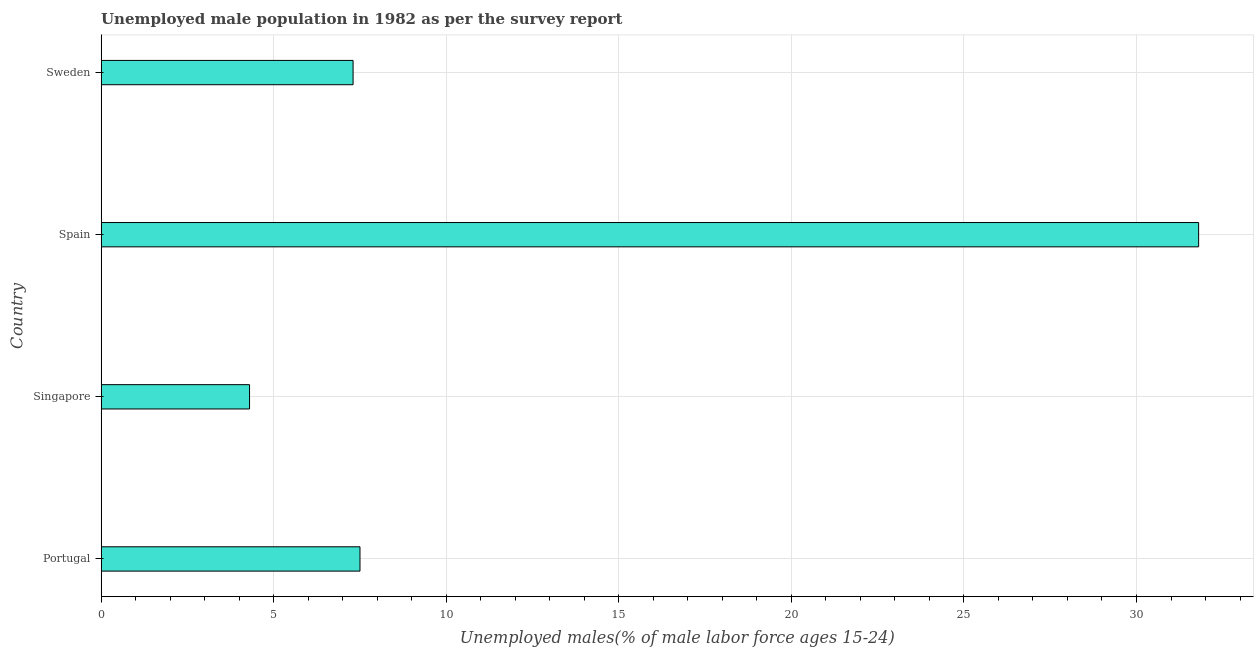Does the graph contain any zero values?
Your answer should be very brief. No. What is the title of the graph?
Provide a succinct answer. Unemployed male population in 1982 as per the survey report. What is the label or title of the X-axis?
Your answer should be very brief. Unemployed males(% of male labor force ages 15-24). What is the label or title of the Y-axis?
Your response must be concise. Country. What is the unemployed male youth in Spain?
Give a very brief answer. 31.8. Across all countries, what is the maximum unemployed male youth?
Ensure brevity in your answer.  31.8. Across all countries, what is the minimum unemployed male youth?
Give a very brief answer. 4.3. In which country was the unemployed male youth minimum?
Provide a short and direct response. Singapore. What is the sum of the unemployed male youth?
Ensure brevity in your answer.  50.9. What is the difference between the unemployed male youth in Portugal and Spain?
Make the answer very short. -24.3. What is the average unemployed male youth per country?
Ensure brevity in your answer.  12.72. What is the median unemployed male youth?
Your answer should be compact. 7.4. What is the ratio of the unemployed male youth in Portugal to that in Singapore?
Make the answer very short. 1.74. What is the difference between the highest and the second highest unemployed male youth?
Make the answer very short. 24.3. What is the difference between the highest and the lowest unemployed male youth?
Give a very brief answer. 27.5. Are all the bars in the graph horizontal?
Give a very brief answer. Yes. How many countries are there in the graph?
Your answer should be very brief. 4. What is the difference between two consecutive major ticks on the X-axis?
Offer a very short reply. 5. Are the values on the major ticks of X-axis written in scientific E-notation?
Ensure brevity in your answer.  No. What is the Unemployed males(% of male labor force ages 15-24) of Singapore?
Provide a succinct answer. 4.3. What is the Unemployed males(% of male labor force ages 15-24) in Spain?
Keep it short and to the point. 31.8. What is the Unemployed males(% of male labor force ages 15-24) of Sweden?
Your response must be concise. 7.3. What is the difference between the Unemployed males(% of male labor force ages 15-24) in Portugal and Singapore?
Ensure brevity in your answer.  3.2. What is the difference between the Unemployed males(% of male labor force ages 15-24) in Portugal and Spain?
Ensure brevity in your answer.  -24.3. What is the difference between the Unemployed males(% of male labor force ages 15-24) in Portugal and Sweden?
Provide a short and direct response. 0.2. What is the difference between the Unemployed males(% of male labor force ages 15-24) in Singapore and Spain?
Make the answer very short. -27.5. What is the difference between the Unemployed males(% of male labor force ages 15-24) in Spain and Sweden?
Give a very brief answer. 24.5. What is the ratio of the Unemployed males(% of male labor force ages 15-24) in Portugal to that in Singapore?
Give a very brief answer. 1.74. What is the ratio of the Unemployed males(% of male labor force ages 15-24) in Portugal to that in Spain?
Ensure brevity in your answer.  0.24. What is the ratio of the Unemployed males(% of male labor force ages 15-24) in Portugal to that in Sweden?
Offer a very short reply. 1.03. What is the ratio of the Unemployed males(% of male labor force ages 15-24) in Singapore to that in Spain?
Your answer should be very brief. 0.14. What is the ratio of the Unemployed males(% of male labor force ages 15-24) in Singapore to that in Sweden?
Your answer should be compact. 0.59. What is the ratio of the Unemployed males(% of male labor force ages 15-24) in Spain to that in Sweden?
Provide a short and direct response. 4.36. 